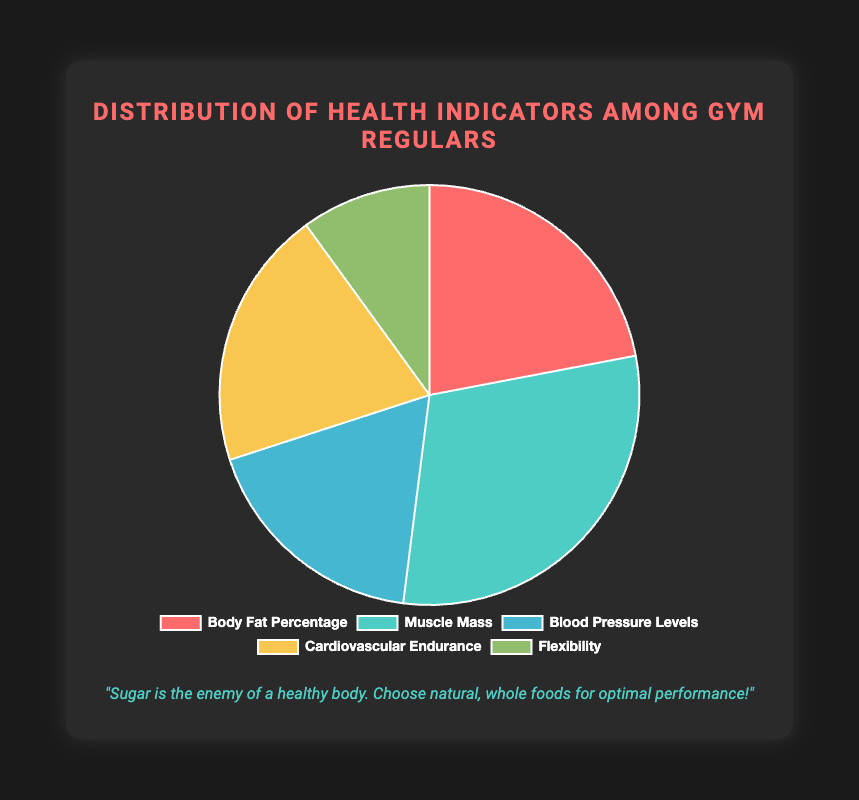Which health indicator has the highest distribution percentage? By looking at the pie chart, the health indicator with the largest slice represents the highest distribution percentage.
Answer: Muscle Mass What is the sum of the percentages of Blood Pressure Levels and Cardiovascular Endurance? Blood Pressure Levels have 18%, and Cardiovascular Endurance is 20%. Adding these two percentages together: 18 + 20 = 38%
Answer: 38% Which health indicator occupies the smallest portion of the pie chart? The smallest slice in the pie chart represents the health indicator with the lowest percentage.
Answer: Flexibility Is the percentage of Body Fat Percentage higher or lower than the percentage of Blood Pressure Levels? Body Fat Percentage is 22%, and Blood Pressure Levels are 18%. Comparing these, 22% is higher than 18%.
Answer: Higher What is the combined percentage of Body Fat Percentage, Blood Pressure Levels, and Flexibility? Adding the percentages of Body Fat Percentage (22%), Blood Pressure Levels (18%), and Flexibility (10%): 22 + 18 + 10 = 50%
Answer: 50% If Muscle Mass is the largest slice, what is its exact percentage? The largest slice representing Muscle Mass has its percentage as shown in the pie chart.
Answer: 30% What is the difference in percentage between Muscle Mass and Cardiovascular Endurance? Muscle Mass is at 30%, and Cardiovascular Endurance is at 20%. The difference between these: 30 - 20 = 10%
Answer: 10% Which colors in the chart represent the highest and lowest percentage health indicators? The slice with the highest percentage (Muscle Mass) is light blue, and the slice with the lowest percentage (Flexibility) is green.
Answer: Light blue (highest) and green (lowest) What proportion of the pie chart is not devoted to Muscle Mass? Muscle Mass is 30%, so the rest of the pie chart is the total percentage minus this value: 100 - 30 = 70%.
Answer: 70% 